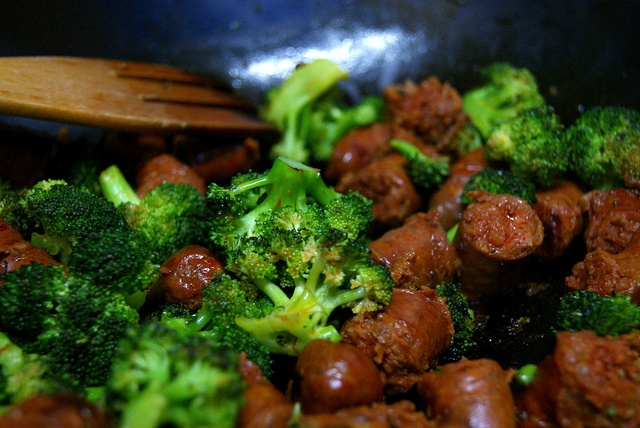Describe the objects in this image and their specific colors. I can see broccoli in black, darkgreen, and green tones, broccoli in black, darkgreen, and green tones, broccoli in black, darkgreen, and green tones, fork in black, olive, and maroon tones, and broccoli in black, darkgreen, maroon, and olive tones in this image. 